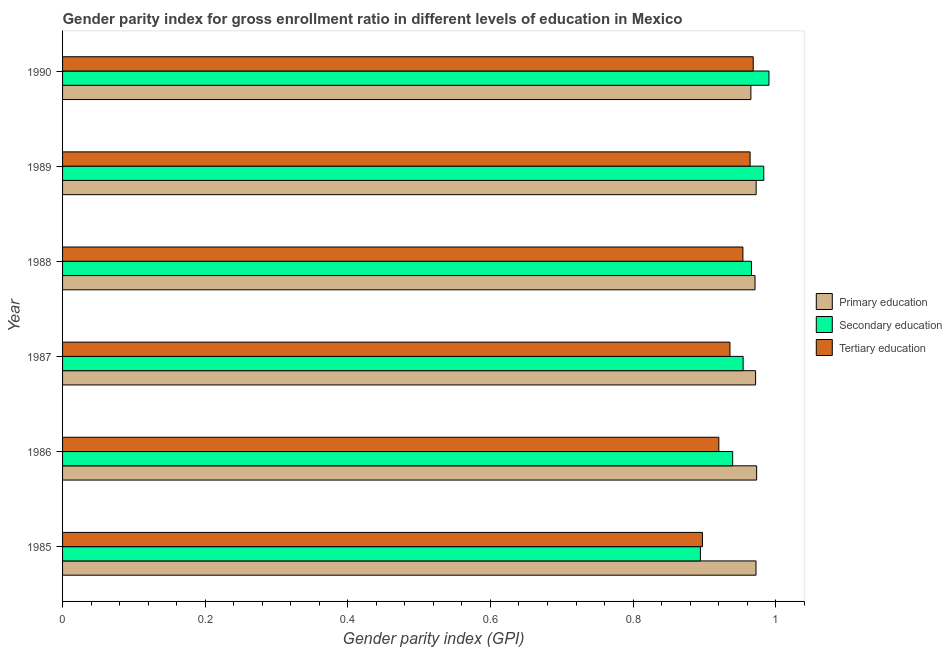How many groups of bars are there?
Your response must be concise. 6. Are the number of bars per tick equal to the number of legend labels?
Keep it short and to the point. Yes. What is the gender parity index in tertiary education in 1988?
Make the answer very short. 0.95. Across all years, what is the maximum gender parity index in tertiary education?
Keep it short and to the point. 0.97. Across all years, what is the minimum gender parity index in tertiary education?
Give a very brief answer. 0.9. In which year was the gender parity index in tertiary education maximum?
Your answer should be compact. 1990. What is the total gender parity index in primary education in the graph?
Your answer should be very brief. 5.83. What is the difference between the gender parity index in tertiary education in 1985 and that in 1989?
Make the answer very short. -0.07. What is the difference between the gender parity index in secondary education in 1989 and the gender parity index in primary education in 1986?
Your answer should be very brief. 0.01. In the year 1985, what is the difference between the gender parity index in tertiary education and gender parity index in secondary education?
Offer a terse response. 0. In how many years, is the gender parity index in primary education greater than 0.88 ?
Your answer should be compact. 6. What is the ratio of the gender parity index in tertiary education in 1986 to that in 1987?
Your response must be concise. 0.98. Is the gender parity index in tertiary education in 1985 less than that in 1987?
Your answer should be compact. Yes. Is the difference between the gender parity index in secondary education in 1986 and 1988 greater than the difference between the gender parity index in tertiary education in 1986 and 1988?
Your answer should be very brief. Yes. What is the difference between the highest and the second highest gender parity index in secondary education?
Offer a terse response. 0.01. What is the difference between the highest and the lowest gender parity index in primary education?
Your response must be concise. 0.01. In how many years, is the gender parity index in secondary education greater than the average gender parity index in secondary education taken over all years?
Ensure brevity in your answer.  3. What does the 2nd bar from the top in 1990 represents?
Offer a terse response. Secondary education. What does the 3rd bar from the bottom in 1987 represents?
Your response must be concise. Tertiary education. Does the graph contain any zero values?
Provide a succinct answer. No. How are the legend labels stacked?
Your response must be concise. Vertical. What is the title of the graph?
Your response must be concise. Gender parity index for gross enrollment ratio in different levels of education in Mexico. Does "Tertiary education" appear as one of the legend labels in the graph?
Your answer should be compact. Yes. What is the label or title of the X-axis?
Give a very brief answer. Gender parity index (GPI). What is the label or title of the Y-axis?
Provide a succinct answer. Year. What is the Gender parity index (GPI) of Primary education in 1985?
Offer a terse response. 0.97. What is the Gender parity index (GPI) in Secondary education in 1985?
Your answer should be compact. 0.89. What is the Gender parity index (GPI) in Tertiary education in 1985?
Your answer should be very brief. 0.9. What is the Gender parity index (GPI) in Primary education in 1986?
Your answer should be compact. 0.97. What is the Gender parity index (GPI) of Secondary education in 1986?
Keep it short and to the point. 0.94. What is the Gender parity index (GPI) in Tertiary education in 1986?
Give a very brief answer. 0.92. What is the Gender parity index (GPI) of Primary education in 1987?
Your response must be concise. 0.97. What is the Gender parity index (GPI) in Secondary education in 1987?
Give a very brief answer. 0.95. What is the Gender parity index (GPI) in Tertiary education in 1987?
Provide a succinct answer. 0.94. What is the Gender parity index (GPI) of Primary education in 1988?
Provide a short and direct response. 0.97. What is the Gender parity index (GPI) of Secondary education in 1988?
Your answer should be compact. 0.97. What is the Gender parity index (GPI) of Tertiary education in 1988?
Provide a succinct answer. 0.95. What is the Gender parity index (GPI) in Primary education in 1989?
Keep it short and to the point. 0.97. What is the Gender parity index (GPI) in Secondary education in 1989?
Make the answer very short. 0.98. What is the Gender parity index (GPI) of Tertiary education in 1989?
Make the answer very short. 0.96. What is the Gender parity index (GPI) of Primary education in 1990?
Give a very brief answer. 0.97. What is the Gender parity index (GPI) in Secondary education in 1990?
Your answer should be very brief. 0.99. What is the Gender parity index (GPI) of Tertiary education in 1990?
Make the answer very short. 0.97. Across all years, what is the maximum Gender parity index (GPI) of Primary education?
Offer a terse response. 0.97. Across all years, what is the maximum Gender parity index (GPI) of Secondary education?
Ensure brevity in your answer.  0.99. Across all years, what is the maximum Gender parity index (GPI) of Tertiary education?
Give a very brief answer. 0.97. Across all years, what is the minimum Gender parity index (GPI) in Primary education?
Offer a terse response. 0.97. Across all years, what is the minimum Gender parity index (GPI) in Secondary education?
Provide a succinct answer. 0.89. Across all years, what is the minimum Gender parity index (GPI) of Tertiary education?
Keep it short and to the point. 0.9. What is the total Gender parity index (GPI) of Primary education in the graph?
Keep it short and to the point. 5.83. What is the total Gender parity index (GPI) in Secondary education in the graph?
Your answer should be very brief. 5.73. What is the total Gender parity index (GPI) in Tertiary education in the graph?
Keep it short and to the point. 5.64. What is the difference between the Gender parity index (GPI) of Primary education in 1985 and that in 1986?
Offer a very short reply. -0. What is the difference between the Gender parity index (GPI) of Secondary education in 1985 and that in 1986?
Your response must be concise. -0.05. What is the difference between the Gender parity index (GPI) in Tertiary education in 1985 and that in 1986?
Give a very brief answer. -0.02. What is the difference between the Gender parity index (GPI) in Primary education in 1985 and that in 1987?
Make the answer very short. 0. What is the difference between the Gender parity index (GPI) of Secondary education in 1985 and that in 1987?
Provide a succinct answer. -0.06. What is the difference between the Gender parity index (GPI) in Tertiary education in 1985 and that in 1987?
Offer a terse response. -0.04. What is the difference between the Gender parity index (GPI) of Primary education in 1985 and that in 1988?
Give a very brief answer. 0. What is the difference between the Gender parity index (GPI) of Secondary education in 1985 and that in 1988?
Provide a succinct answer. -0.07. What is the difference between the Gender parity index (GPI) in Tertiary education in 1985 and that in 1988?
Your answer should be compact. -0.06. What is the difference between the Gender parity index (GPI) in Primary education in 1985 and that in 1989?
Ensure brevity in your answer.  -0. What is the difference between the Gender parity index (GPI) of Secondary education in 1985 and that in 1989?
Offer a very short reply. -0.09. What is the difference between the Gender parity index (GPI) of Tertiary education in 1985 and that in 1989?
Provide a succinct answer. -0.07. What is the difference between the Gender parity index (GPI) of Primary education in 1985 and that in 1990?
Provide a short and direct response. 0.01. What is the difference between the Gender parity index (GPI) in Secondary education in 1985 and that in 1990?
Ensure brevity in your answer.  -0.1. What is the difference between the Gender parity index (GPI) of Tertiary education in 1985 and that in 1990?
Give a very brief answer. -0.07. What is the difference between the Gender parity index (GPI) in Primary education in 1986 and that in 1987?
Your answer should be very brief. 0. What is the difference between the Gender parity index (GPI) in Secondary education in 1986 and that in 1987?
Provide a short and direct response. -0.01. What is the difference between the Gender parity index (GPI) of Tertiary education in 1986 and that in 1987?
Your answer should be very brief. -0.02. What is the difference between the Gender parity index (GPI) of Primary education in 1986 and that in 1988?
Make the answer very short. 0. What is the difference between the Gender parity index (GPI) of Secondary education in 1986 and that in 1988?
Provide a short and direct response. -0.03. What is the difference between the Gender parity index (GPI) in Tertiary education in 1986 and that in 1988?
Provide a short and direct response. -0.03. What is the difference between the Gender parity index (GPI) in Primary education in 1986 and that in 1989?
Your answer should be very brief. 0. What is the difference between the Gender parity index (GPI) in Secondary education in 1986 and that in 1989?
Offer a very short reply. -0.04. What is the difference between the Gender parity index (GPI) in Tertiary education in 1986 and that in 1989?
Offer a very short reply. -0.04. What is the difference between the Gender parity index (GPI) in Primary education in 1986 and that in 1990?
Your response must be concise. 0.01. What is the difference between the Gender parity index (GPI) in Secondary education in 1986 and that in 1990?
Your answer should be compact. -0.05. What is the difference between the Gender parity index (GPI) in Tertiary education in 1986 and that in 1990?
Provide a succinct answer. -0.05. What is the difference between the Gender parity index (GPI) of Primary education in 1987 and that in 1988?
Make the answer very short. 0. What is the difference between the Gender parity index (GPI) in Secondary education in 1987 and that in 1988?
Give a very brief answer. -0.01. What is the difference between the Gender parity index (GPI) in Tertiary education in 1987 and that in 1988?
Your response must be concise. -0.02. What is the difference between the Gender parity index (GPI) of Primary education in 1987 and that in 1989?
Provide a succinct answer. -0. What is the difference between the Gender parity index (GPI) of Secondary education in 1987 and that in 1989?
Provide a succinct answer. -0.03. What is the difference between the Gender parity index (GPI) of Tertiary education in 1987 and that in 1989?
Your response must be concise. -0.03. What is the difference between the Gender parity index (GPI) of Primary education in 1987 and that in 1990?
Offer a very short reply. 0.01. What is the difference between the Gender parity index (GPI) of Secondary education in 1987 and that in 1990?
Provide a short and direct response. -0.04. What is the difference between the Gender parity index (GPI) of Tertiary education in 1987 and that in 1990?
Keep it short and to the point. -0.03. What is the difference between the Gender parity index (GPI) in Primary education in 1988 and that in 1989?
Your answer should be compact. -0. What is the difference between the Gender parity index (GPI) of Secondary education in 1988 and that in 1989?
Make the answer very short. -0.02. What is the difference between the Gender parity index (GPI) of Tertiary education in 1988 and that in 1989?
Provide a short and direct response. -0.01. What is the difference between the Gender parity index (GPI) of Primary education in 1988 and that in 1990?
Provide a short and direct response. 0.01. What is the difference between the Gender parity index (GPI) of Secondary education in 1988 and that in 1990?
Your answer should be compact. -0.02. What is the difference between the Gender parity index (GPI) of Tertiary education in 1988 and that in 1990?
Your response must be concise. -0.01. What is the difference between the Gender parity index (GPI) in Primary education in 1989 and that in 1990?
Your response must be concise. 0.01. What is the difference between the Gender parity index (GPI) of Secondary education in 1989 and that in 1990?
Offer a very short reply. -0.01. What is the difference between the Gender parity index (GPI) in Tertiary education in 1989 and that in 1990?
Provide a succinct answer. -0. What is the difference between the Gender parity index (GPI) in Primary education in 1985 and the Gender parity index (GPI) in Secondary education in 1986?
Your answer should be very brief. 0.03. What is the difference between the Gender parity index (GPI) in Primary education in 1985 and the Gender parity index (GPI) in Tertiary education in 1986?
Provide a succinct answer. 0.05. What is the difference between the Gender parity index (GPI) of Secondary education in 1985 and the Gender parity index (GPI) of Tertiary education in 1986?
Your response must be concise. -0.03. What is the difference between the Gender parity index (GPI) in Primary education in 1985 and the Gender parity index (GPI) in Secondary education in 1987?
Make the answer very short. 0.02. What is the difference between the Gender parity index (GPI) of Primary education in 1985 and the Gender parity index (GPI) of Tertiary education in 1987?
Give a very brief answer. 0.04. What is the difference between the Gender parity index (GPI) in Secondary education in 1985 and the Gender parity index (GPI) in Tertiary education in 1987?
Provide a succinct answer. -0.04. What is the difference between the Gender parity index (GPI) of Primary education in 1985 and the Gender parity index (GPI) of Secondary education in 1988?
Ensure brevity in your answer.  0.01. What is the difference between the Gender parity index (GPI) in Primary education in 1985 and the Gender parity index (GPI) in Tertiary education in 1988?
Make the answer very short. 0.02. What is the difference between the Gender parity index (GPI) in Secondary education in 1985 and the Gender parity index (GPI) in Tertiary education in 1988?
Your response must be concise. -0.06. What is the difference between the Gender parity index (GPI) of Primary education in 1985 and the Gender parity index (GPI) of Secondary education in 1989?
Provide a short and direct response. -0.01. What is the difference between the Gender parity index (GPI) of Primary education in 1985 and the Gender parity index (GPI) of Tertiary education in 1989?
Ensure brevity in your answer.  0.01. What is the difference between the Gender parity index (GPI) of Secondary education in 1985 and the Gender parity index (GPI) of Tertiary education in 1989?
Offer a very short reply. -0.07. What is the difference between the Gender parity index (GPI) in Primary education in 1985 and the Gender parity index (GPI) in Secondary education in 1990?
Make the answer very short. -0.02. What is the difference between the Gender parity index (GPI) in Primary education in 1985 and the Gender parity index (GPI) in Tertiary education in 1990?
Offer a terse response. 0. What is the difference between the Gender parity index (GPI) in Secondary education in 1985 and the Gender parity index (GPI) in Tertiary education in 1990?
Provide a short and direct response. -0.07. What is the difference between the Gender parity index (GPI) in Primary education in 1986 and the Gender parity index (GPI) in Secondary education in 1987?
Offer a terse response. 0.02. What is the difference between the Gender parity index (GPI) of Primary education in 1986 and the Gender parity index (GPI) of Tertiary education in 1987?
Ensure brevity in your answer.  0.04. What is the difference between the Gender parity index (GPI) in Secondary education in 1986 and the Gender parity index (GPI) in Tertiary education in 1987?
Offer a terse response. 0. What is the difference between the Gender parity index (GPI) in Primary education in 1986 and the Gender parity index (GPI) in Secondary education in 1988?
Keep it short and to the point. 0.01. What is the difference between the Gender parity index (GPI) in Primary education in 1986 and the Gender parity index (GPI) in Tertiary education in 1988?
Your answer should be compact. 0.02. What is the difference between the Gender parity index (GPI) of Secondary education in 1986 and the Gender parity index (GPI) of Tertiary education in 1988?
Give a very brief answer. -0.01. What is the difference between the Gender parity index (GPI) of Primary education in 1986 and the Gender parity index (GPI) of Secondary education in 1989?
Offer a very short reply. -0.01. What is the difference between the Gender parity index (GPI) of Primary education in 1986 and the Gender parity index (GPI) of Tertiary education in 1989?
Make the answer very short. 0.01. What is the difference between the Gender parity index (GPI) in Secondary education in 1986 and the Gender parity index (GPI) in Tertiary education in 1989?
Your response must be concise. -0.02. What is the difference between the Gender parity index (GPI) in Primary education in 1986 and the Gender parity index (GPI) in Secondary education in 1990?
Offer a very short reply. -0.02. What is the difference between the Gender parity index (GPI) of Primary education in 1986 and the Gender parity index (GPI) of Tertiary education in 1990?
Ensure brevity in your answer.  0. What is the difference between the Gender parity index (GPI) in Secondary education in 1986 and the Gender parity index (GPI) in Tertiary education in 1990?
Offer a terse response. -0.03. What is the difference between the Gender parity index (GPI) in Primary education in 1987 and the Gender parity index (GPI) in Secondary education in 1988?
Your answer should be compact. 0.01. What is the difference between the Gender parity index (GPI) in Primary education in 1987 and the Gender parity index (GPI) in Tertiary education in 1988?
Your answer should be very brief. 0.02. What is the difference between the Gender parity index (GPI) of Primary education in 1987 and the Gender parity index (GPI) of Secondary education in 1989?
Give a very brief answer. -0.01. What is the difference between the Gender parity index (GPI) of Primary education in 1987 and the Gender parity index (GPI) of Tertiary education in 1989?
Make the answer very short. 0.01. What is the difference between the Gender parity index (GPI) in Secondary education in 1987 and the Gender parity index (GPI) in Tertiary education in 1989?
Your response must be concise. -0.01. What is the difference between the Gender parity index (GPI) in Primary education in 1987 and the Gender parity index (GPI) in Secondary education in 1990?
Make the answer very short. -0.02. What is the difference between the Gender parity index (GPI) of Primary education in 1987 and the Gender parity index (GPI) of Tertiary education in 1990?
Provide a short and direct response. 0. What is the difference between the Gender parity index (GPI) in Secondary education in 1987 and the Gender parity index (GPI) in Tertiary education in 1990?
Provide a succinct answer. -0.01. What is the difference between the Gender parity index (GPI) of Primary education in 1988 and the Gender parity index (GPI) of Secondary education in 1989?
Give a very brief answer. -0.01. What is the difference between the Gender parity index (GPI) of Primary education in 1988 and the Gender parity index (GPI) of Tertiary education in 1989?
Provide a short and direct response. 0.01. What is the difference between the Gender parity index (GPI) in Secondary education in 1988 and the Gender parity index (GPI) in Tertiary education in 1989?
Give a very brief answer. 0. What is the difference between the Gender parity index (GPI) in Primary education in 1988 and the Gender parity index (GPI) in Secondary education in 1990?
Provide a succinct answer. -0.02. What is the difference between the Gender parity index (GPI) in Primary education in 1988 and the Gender parity index (GPI) in Tertiary education in 1990?
Provide a succinct answer. 0. What is the difference between the Gender parity index (GPI) of Secondary education in 1988 and the Gender parity index (GPI) of Tertiary education in 1990?
Offer a very short reply. -0. What is the difference between the Gender parity index (GPI) of Primary education in 1989 and the Gender parity index (GPI) of Secondary education in 1990?
Offer a terse response. -0.02. What is the difference between the Gender parity index (GPI) of Primary education in 1989 and the Gender parity index (GPI) of Tertiary education in 1990?
Your response must be concise. 0. What is the difference between the Gender parity index (GPI) of Secondary education in 1989 and the Gender parity index (GPI) of Tertiary education in 1990?
Offer a terse response. 0.01. What is the average Gender parity index (GPI) in Primary education per year?
Keep it short and to the point. 0.97. What is the average Gender parity index (GPI) in Secondary education per year?
Ensure brevity in your answer.  0.95. In the year 1985, what is the difference between the Gender parity index (GPI) of Primary education and Gender parity index (GPI) of Secondary education?
Your answer should be compact. 0.08. In the year 1985, what is the difference between the Gender parity index (GPI) of Primary education and Gender parity index (GPI) of Tertiary education?
Keep it short and to the point. 0.08. In the year 1985, what is the difference between the Gender parity index (GPI) in Secondary education and Gender parity index (GPI) in Tertiary education?
Offer a very short reply. -0. In the year 1986, what is the difference between the Gender parity index (GPI) of Primary education and Gender parity index (GPI) of Secondary education?
Ensure brevity in your answer.  0.03. In the year 1986, what is the difference between the Gender parity index (GPI) in Primary education and Gender parity index (GPI) in Tertiary education?
Provide a succinct answer. 0.05. In the year 1986, what is the difference between the Gender parity index (GPI) in Secondary education and Gender parity index (GPI) in Tertiary education?
Provide a succinct answer. 0.02. In the year 1987, what is the difference between the Gender parity index (GPI) in Primary education and Gender parity index (GPI) in Secondary education?
Your response must be concise. 0.02. In the year 1987, what is the difference between the Gender parity index (GPI) in Primary education and Gender parity index (GPI) in Tertiary education?
Ensure brevity in your answer.  0.04. In the year 1987, what is the difference between the Gender parity index (GPI) of Secondary education and Gender parity index (GPI) of Tertiary education?
Your answer should be very brief. 0.02. In the year 1988, what is the difference between the Gender parity index (GPI) of Primary education and Gender parity index (GPI) of Secondary education?
Keep it short and to the point. 0.01. In the year 1988, what is the difference between the Gender parity index (GPI) in Primary education and Gender parity index (GPI) in Tertiary education?
Keep it short and to the point. 0.02. In the year 1988, what is the difference between the Gender parity index (GPI) of Secondary education and Gender parity index (GPI) of Tertiary education?
Your answer should be compact. 0.01. In the year 1989, what is the difference between the Gender parity index (GPI) of Primary education and Gender parity index (GPI) of Secondary education?
Your answer should be very brief. -0.01. In the year 1989, what is the difference between the Gender parity index (GPI) of Primary education and Gender parity index (GPI) of Tertiary education?
Make the answer very short. 0.01. In the year 1989, what is the difference between the Gender parity index (GPI) in Secondary education and Gender parity index (GPI) in Tertiary education?
Offer a terse response. 0.02. In the year 1990, what is the difference between the Gender parity index (GPI) of Primary education and Gender parity index (GPI) of Secondary education?
Your answer should be very brief. -0.03. In the year 1990, what is the difference between the Gender parity index (GPI) of Primary education and Gender parity index (GPI) of Tertiary education?
Provide a short and direct response. -0. In the year 1990, what is the difference between the Gender parity index (GPI) in Secondary education and Gender parity index (GPI) in Tertiary education?
Provide a succinct answer. 0.02. What is the ratio of the Gender parity index (GPI) of Secondary education in 1985 to that in 1986?
Offer a terse response. 0.95. What is the ratio of the Gender parity index (GPI) of Tertiary education in 1985 to that in 1986?
Keep it short and to the point. 0.98. What is the ratio of the Gender parity index (GPI) in Primary education in 1985 to that in 1987?
Make the answer very short. 1. What is the ratio of the Gender parity index (GPI) in Secondary education in 1985 to that in 1987?
Your response must be concise. 0.94. What is the ratio of the Gender parity index (GPI) in Tertiary education in 1985 to that in 1987?
Offer a terse response. 0.96. What is the ratio of the Gender parity index (GPI) in Secondary education in 1985 to that in 1988?
Offer a very short reply. 0.93. What is the ratio of the Gender parity index (GPI) of Tertiary education in 1985 to that in 1988?
Your answer should be compact. 0.94. What is the ratio of the Gender parity index (GPI) in Secondary education in 1985 to that in 1989?
Your answer should be compact. 0.91. What is the ratio of the Gender parity index (GPI) of Tertiary education in 1985 to that in 1989?
Your answer should be compact. 0.93. What is the ratio of the Gender parity index (GPI) of Primary education in 1985 to that in 1990?
Give a very brief answer. 1.01. What is the ratio of the Gender parity index (GPI) of Secondary education in 1985 to that in 1990?
Ensure brevity in your answer.  0.9. What is the ratio of the Gender parity index (GPI) of Tertiary education in 1985 to that in 1990?
Provide a succinct answer. 0.93. What is the ratio of the Gender parity index (GPI) in Secondary education in 1986 to that in 1987?
Ensure brevity in your answer.  0.98. What is the ratio of the Gender parity index (GPI) of Tertiary education in 1986 to that in 1987?
Your answer should be compact. 0.98. What is the ratio of the Gender parity index (GPI) of Secondary education in 1986 to that in 1988?
Provide a succinct answer. 0.97. What is the ratio of the Gender parity index (GPI) of Tertiary education in 1986 to that in 1988?
Make the answer very short. 0.96. What is the ratio of the Gender parity index (GPI) in Secondary education in 1986 to that in 1989?
Give a very brief answer. 0.96. What is the ratio of the Gender parity index (GPI) in Tertiary education in 1986 to that in 1989?
Make the answer very short. 0.95. What is the ratio of the Gender parity index (GPI) of Primary education in 1986 to that in 1990?
Give a very brief answer. 1.01. What is the ratio of the Gender parity index (GPI) of Secondary education in 1986 to that in 1990?
Make the answer very short. 0.95. What is the ratio of the Gender parity index (GPI) in Tertiary education in 1986 to that in 1990?
Your answer should be compact. 0.95. What is the ratio of the Gender parity index (GPI) in Secondary education in 1987 to that in 1988?
Keep it short and to the point. 0.99. What is the ratio of the Gender parity index (GPI) of Tertiary education in 1987 to that in 1988?
Offer a terse response. 0.98. What is the ratio of the Gender parity index (GPI) in Secondary education in 1987 to that in 1989?
Give a very brief answer. 0.97. What is the ratio of the Gender parity index (GPI) in Tertiary education in 1987 to that in 1989?
Provide a short and direct response. 0.97. What is the ratio of the Gender parity index (GPI) of Primary education in 1987 to that in 1990?
Your response must be concise. 1.01. What is the ratio of the Gender parity index (GPI) in Secondary education in 1987 to that in 1990?
Ensure brevity in your answer.  0.96. What is the ratio of the Gender parity index (GPI) of Tertiary education in 1987 to that in 1990?
Keep it short and to the point. 0.97. What is the ratio of the Gender parity index (GPI) in Primary education in 1988 to that in 1989?
Offer a terse response. 1. What is the ratio of the Gender parity index (GPI) in Secondary education in 1988 to that in 1989?
Provide a succinct answer. 0.98. What is the ratio of the Gender parity index (GPI) in Secondary education in 1988 to that in 1990?
Your response must be concise. 0.98. What is the ratio of the Gender parity index (GPI) of Tertiary education in 1988 to that in 1990?
Ensure brevity in your answer.  0.99. What is the ratio of the Gender parity index (GPI) in Primary education in 1989 to that in 1990?
Your answer should be very brief. 1.01. What is the ratio of the Gender parity index (GPI) in Secondary education in 1989 to that in 1990?
Your answer should be compact. 0.99. What is the difference between the highest and the second highest Gender parity index (GPI) in Primary education?
Ensure brevity in your answer.  0. What is the difference between the highest and the second highest Gender parity index (GPI) of Secondary education?
Keep it short and to the point. 0.01. What is the difference between the highest and the second highest Gender parity index (GPI) in Tertiary education?
Ensure brevity in your answer.  0. What is the difference between the highest and the lowest Gender parity index (GPI) in Primary education?
Give a very brief answer. 0.01. What is the difference between the highest and the lowest Gender parity index (GPI) of Secondary education?
Offer a terse response. 0.1. What is the difference between the highest and the lowest Gender parity index (GPI) of Tertiary education?
Your response must be concise. 0.07. 